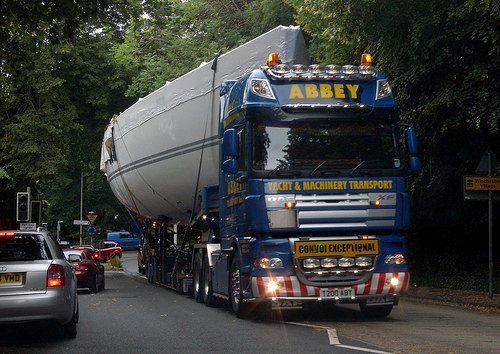<image>
Can you confirm if the boat is behind the truck? Yes. From this viewpoint, the boat is positioned behind the truck, with the truck partially or fully occluding the boat. Is the truck in front of the road? No. The truck is not in front of the road. The spatial positioning shows a different relationship between these objects. 